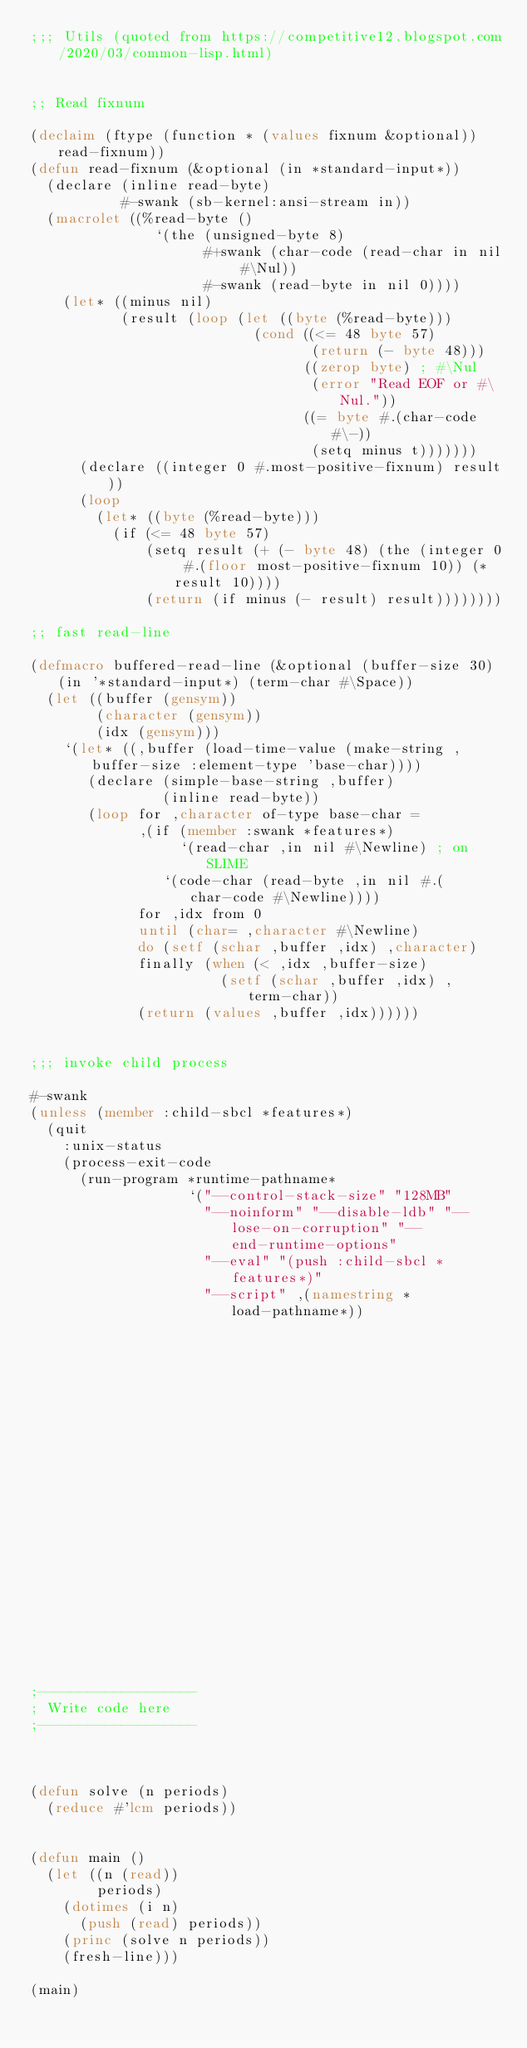<code> <loc_0><loc_0><loc_500><loc_500><_Lisp_>;;; Utils (quoted from https://competitive12.blogspot.com/2020/03/common-lisp.html)


;; Read fixnum

(declaim (ftype (function * (values fixnum &optional)) read-fixnum))
(defun read-fixnum (&optional (in *standard-input*))
  (declare (inline read-byte)
           #-swank (sb-kernel:ansi-stream in))
  (macrolet ((%read-byte ()
               `(the (unsigned-byte 8)
                     #+swank (char-code (read-char in nil #\Nul))
                     #-swank (read-byte in nil 0))))
    (let* ((minus nil)
           (result (loop (let ((byte (%read-byte)))
                           (cond ((<= 48 byte 57)
                                  (return (- byte 48)))
                                 ((zerop byte) ; #\Nul
                                  (error "Read EOF or #\Nul."))
                                 ((= byte #.(char-code #\-))
                                  (setq minus t)))))))
      (declare ((integer 0 #.most-positive-fixnum) result))
      (loop
        (let* ((byte (%read-byte)))
          (if (<= 48 byte 57)
              (setq result (+ (- byte 48) (the (integer 0 #.(floor most-positive-fixnum 10)) (* result 10))))
              (return (if minus (- result) result))))))))

;; fast read-line

(defmacro buffered-read-line (&optional (buffer-size 30) (in '*standard-input*) (term-char #\Space))
  (let ((buffer (gensym))
        (character (gensym))
        (idx (gensym)))
    `(let* ((,buffer (load-time-value (make-string ,buffer-size :element-type 'base-char))))
       (declare (simple-base-string ,buffer)
                (inline read-byte))
       (loop for ,character of-type base-char =
             ,(if (member :swank *features*)
                  `(read-char ,in nil #\Newline) ; on SLIME
                `(code-char (read-byte ,in nil #.(char-code #\Newline))))
             for ,idx from 0
             until (char= ,character #\Newline)
             do (setf (schar ,buffer ,idx) ,character)
             finally (when (< ,idx ,buffer-size)
                       (setf (schar ,buffer ,idx) ,term-char))
             (return (values ,buffer ,idx))))))


;;; invoke child process

#-swank
(unless (member :child-sbcl *features*)
  (quit
    :unix-status
    (process-exit-code
      (run-program *runtime-pathname*
                   `("--control-stack-size" "128MB"
                     "--noinform" "--disable-ldb" "--lose-on-corruption" "--end-runtime-options"
                     "--eval" "(push :child-sbcl *features*)"
                     "--script" ,(namestring *load-pathname*))
                                                                 :output t :error t :input t))))



;-------------------
; Write code here
;-------------------



(defun solve (n periods)
  (reduce #'lcm periods))


(defun main ()
  (let ((n (read))
        periods)
    (dotimes (i n)
      (push (read) periods))
    (princ (solve n periods))
    (fresh-line)))

(main)
</code> 